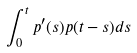Convert formula to latex. <formula><loc_0><loc_0><loc_500><loc_500>\int _ { 0 } ^ { t } p ^ { \prime } ( s ) p ( t - s ) d s</formula> 